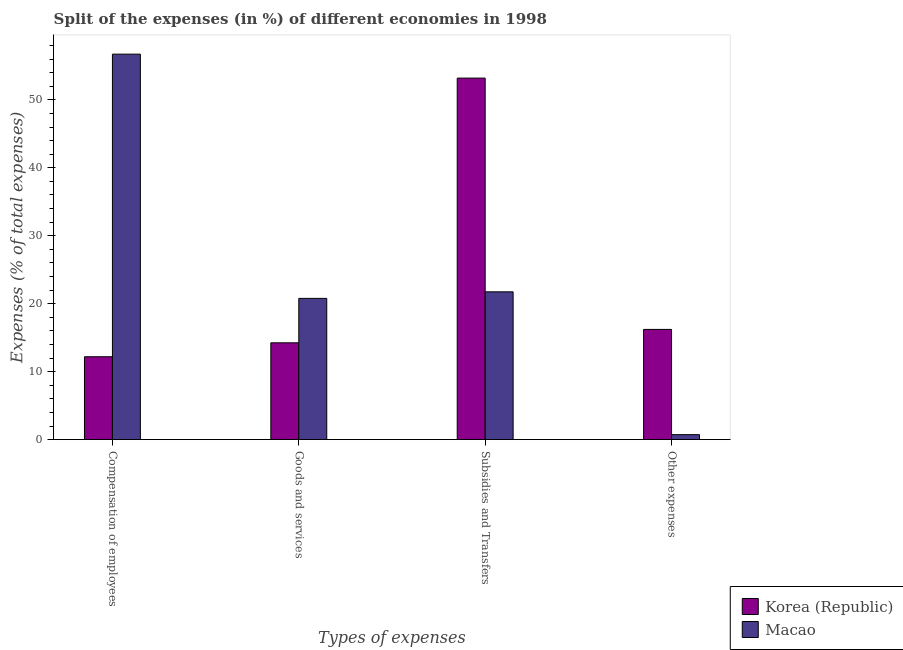How many groups of bars are there?
Ensure brevity in your answer.  4. Are the number of bars on each tick of the X-axis equal?
Your answer should be very brief. Yes. What is the label of the 1st group of bars from the left?
Make the answer very short. Compensation of employees. What is the percentage of amount spent on goods and services in Macao?
Offer a very short reply. 20.78. Across all countries, what is the maximum percentage of amount spent on subsidies?
Ensure brevity in your answer.  53.2. Across all countries, what is the minimum percentage of amount spent on other expenses?
Make the answer very short. 0.73. What is the total percentage of amount spent on other expenses in the graph?
Provide a short and direct response. 16.95. What is the difference between the percentage of amount spent on other expenses in Macao and that in Korea (Republic)?
Give a very brief answer. -15.49. What is the difference between the percentage of amount spent on other expenses in Macao and the percentage of amount spent on goods and services in Korea (Republic)?
Your answer should be very brief. -13.51. What is the average percentage of amount spent on other expenses per country?
Offer a terse response. 8.47. What is the difference between the percentage of amount spent on subsidies and percentage of amount spent on compensation of employees in Macao?
Ensure brevity in your answer.  -34.98. In how many countries, is the percentage of amount spent on other expenses greater than 26 %?
Ensure brevity in your answer.  0. What is the ratio of the percentage of amount spent on goods and services in Macao to that in Korea (Republic)?
Give a very brief answer. 1.46. Is the percentage of amount spent on subsidies in Korea (Republic) less than that in Macao?
Make the answer very short. No. What is the difference between the highest and the second highest percentage of amount spent on goods and services?
Provide a succinct answer. 6.54. What is the difference between the highest and the lowest percentage of amount spent on other expenses?
Provide a succinct answer. 15.49. What does the 1st bar from the right in Goods and services represents?
Provide a succinct answer. Macao. How many bars are there?
Your answer should be very brief. 8. Are all the bars in the graph horizontal?
Your answer should be compact. No. How many countries are there in the graph?
Offer a terse response. 2. What is the difference between two consecutive major ticks on the Y-axis?
Provide a succinct answer. 10. Are the values on the major ticks of Y-axis written in scientific E-notation?
Provide a short and direct response. No. Does the graph contain any zero values?
Your answer should be compact. No. What is the title of the graph?
Provide a succinct answer. Split of the expenses (in %) of different economies in 1998. What is the label or title of the X-axis?
Offer a terse response. Types of expenses. What is the label or title of the Y-axis?
Give a very brief answer. Expenses (% of total expenses). What is the Expenses (% of total expenses) of Korea (Republic) in Compensation of employees?
Your answer should be compact. 12.2. What is the Expenses (% of total expenses) in Macao in Compensation of employees?
Your response must be concise. 56.73. What is the Expenses (% of total expenses) in Korea (Republic) in Goods and services?
Your answer should be compact. 14.24. What is the Expenses (% of total expenses) in Macao in Goods and services?
Provide a short and direct response. 20.78. What is the Expenses (% of total expenses) of Korea (Republic) in Subsidies and Transfers?
Provide a succinct answer. 53.2. What is the Expenses (% of total expenses) of Macao in Subsidies and Transfers?
Ensure brevity in your answer.  21.75. What is the Expenses (% of total expenses) of Korea (Republic) in Other expenses?
Provide a succinct answer. 16.22. What is the Expenses (% of total expenses) in Macao in Other expenses?
Provide a short and direct response. 0.73. Across all Types of expenses, what is the maximum Expenses (% of total expenses) of Korea (Republic)?
Keep it short and to the point. 53.2. Across all Types of expenses, what is the maximum Expenses (% of total expenses) of Macao?
Keep it short and to the point. 56.73. Across all Types of expenses, what is the minimum Expenses (% of total expenses) of Korea (Republic)?
Ensure brevity in your answer.  12.2. Across all Types of expenses, what is the minimum Expenses (% of total expenses) in Macao?
Provide a short and direct response. 0.73. What is the total Expenses (% of total expenses) in Korea (Republic) in the graph?
Provide a short and direct response. 95.86. What is the total Expenses (% of total expenses) of Macao in the graph?
Offer a terse response. 99.99. What is the difference between the Expenses (% of total expenses) in Korea (Republic) in Compensation of employees and that in Goods and services?
Your response must be concise. -2.05. What is the difference between the Expenses (% of total expenses) of Macao in Compensation of employees and that in Goods and services?
Offer a terse response. 35.94. What is the difference between the Expenses (% of total expenses) of Korea (Republic) in Compensation of employees and that in Subsidies and Transfers?
Offer a very short reply. -41. What is the difference between the Expenses (% of total expenses) of Macao in Compensation of employees and that in Subsidies and Transfers?
Give a very brief answer. 34.98. What is the difference between the Expenses (% of total expenses) in Korea (Republic) in Compensation of employees and that in Other expenses?
Keep it short and to the point. -4.02. What is the difference between the Expenses (% of total expenses) of Macao in Compensation of employees and that in Other expenses?
Provide a short and direct response. 56. What is the difference between the Expenses (% of total expenses) of Korea (Republic) in Goods and services and that in Subsidies and Transfers?
Provide a succinct answer. -38.96. What is the difference between the Expenses (% of total expenses) of Macao in Goods and services and that in Subsidies and Transfers?
Ensure brevity in your answer.  -0.96. What is the difference between the Expenses (% of total expenses) of Korea (Republic) in Goods and services and that in Other expenses?
Give a very brief answer. -1.97. What is the difference between the Expenses (% of total expenses) in Macao in Goods and services and that in Other expenses?
Provide a short and direct response. 20.05. What is the difference between the Expenses (% of total expenses) in Korea (Republic) in Subsidies and Transfers and that in Other expenses?
Ensure brevity in your answer.  36.98. What is the difference between the Expenses (% of total expenses) in Macao in Subsidies and Transfers and that in Other expenses?
Offer a terse response. 21.02. What is the difference between the Expenses (% of total expenses) of Korea (Republic) in Compensation of employees and the Expenses (% of total expenses) of Macao in Goods and services?
Keep it short and to the point. -8.59. What is the difference between the Expenses (% of total expenses) in Korea (Republic) in Compensation of employees and the Expenses (% of total expenses) in Macao in Subsidies and Transfers?
Provide a short and direct response. -9.55. What is the difference between the Expenses (% of total expenses) of Korea (Republic) in Compensation of employees and the Expenses (% of total expenses) of Macao in Other expenses?
Ensure brevity in your answer.  11.47. What is the difference between the Expenses (% of total expenses) in Korea (Republic) in Goods and services and the Expenses (% of total expenses) in Macao in Subsidies and Transfers?
Offer a very short reply. -7.5. What is the difference between the Expenses (% of total expenses) in Korea (Republic) in Goods and services and the Expenses (% of total expenses) in Macao in Other expenses?
Ensure brevity in your answer.  13.51. What is the difference between the Expenses (% of total expenses) in Korea (Republic) in Subsidies and Transfers and the Expenses (% of total expenses) in Macao in Other expenses?
Your answer should be very brief. 52.47. What is the average Expenses (% of total expenses) in Korea (Republic) per Types of expenses?
Provide a short and direct response. 23.96. What is the average Expenses (% of total expenses) in Macao per Types of expenses?
Provide a succinct answer. 25. What is the difference between the Expenses (% of total expenses) in Korea (Republic) and Expenses (% of total expenses) in Macao in Compensation of employees?
Ensure brevity in your answer.  -44.53. What is the difference between the Expenses (% of total expenses) of Korea (Republic) and Expenses (% of total expenses) of Macao in Goods and services?
Offer a terse response. -6.54. What is the difference between the Expenses (% of total expenses) in Korea (Republic) and Expenses (% of total expenses) in Macao in Subsidies and Transfers?
Offer a very short reply. 31.45. What is the difference between the Expenses (% of total expenses) of Korea (Republic) and Expenses (% of total expenses) of Macao in Other expenses?
Keep it short and to the point. 15.49. What is the ratio of the Expenses (% of total expenses) of Korea (Republic) in Compensation of employees to that in Goods and services?
Your answer should be compact. 0.86. What is the ratio of the Expenses (% of total expenses) in Macao in Compensation of employees to that in Goods and services?
Offer a terse response. 2.73. What is the ratio of the Expenses (% of total expenses) in Korea (Republic) in Compensation of employees to that in Subsidies and Transfers?
Provide a short and direct response. 0.23. What is the ratio of the Expenses (% of total expenses) of Macao in Compensation of employees to that in Subsidies and Transfers?
Keep it short and to the point. 2.61. What is the ratio of the Expenses (% of total expenses) in Korea (Republic) in Compensation of employees to that in Other expenses?
Offer a terse response. 0.75. What is the ratio of the Expenses (% of total expenses) in Macao in Compensation of employees to that in Other expenses?
Your response must be concise. 77.65. What is the ratio of the Expenses (% of total expenses) of Korea (Republic) in Goods and services to that in Subsidies and Transfers?
Your answer should be very brief. 0.27. What is the ratio of the Expenses (% of total expenses) of Macao in Goods and services to that in Subsidies and Transfers?
Your answer should be very brief. 0.96. What is the ratio of the Expenses (% of total expenses) of Korea (Republic) in Goods and services to that in Other expenses?
Give a very brief answer. 0.88. What is the ratio of the Expenses (% of total expenses) in Macao in Goods and services to that in Other expenses?
Offer a very short reply. 28.45. What is the ratio of the Expenses (% of total expenses) of Korea (Republic) in Subsidies and Transfers to that in Other expenses?
Ensure brevity in your answer.  3.28. What is the ratio of the Expenses (% of total expenses) of Macao in Subsidies and Transfers to that in Other expenses?
Keep it short and to the point. 29.77. What is the difference between the highest and the second highest Expenses (% of total expenses) of Korea (Republic)?
Keep it short and to the point. 36.98. What is the difference between the highest and the second highest Expenses (% of total expenses) in Macao?
Offer a very short reply. 34.98. What is the difference between the highest and the lowest Expenses (% of total expenses) of Korea (Republic)?
Give a very brief answer. 41. What is the difference between the highest and the lowest Expenses (% of total expenses) in Macao?
Offer a very short reply. 56. 